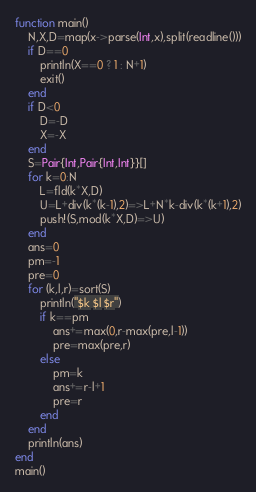Convert code to text. <code><loc_0><loc_0><loc_500><loc_500><_Julia_>function main()
	N,X,D=map(x->parse(Int,x),split(readline()))
	if D==0
		println(X==0 ? 1 : N+1)
		exit()
	end
	if D<0
		D=-D
		X=-X
	end
	S=Pair{Int,Pair{Int,Int}}[]
	for k=0:N
		L=fld(k*X,D)
		U=L+div(k*(k-1),2)=>L+N*k-div(k*(k+1),2)
		push!(S,mod(k*X,D)=>U)
	end
	ans=0
	pm=-1
	pre=0
	for (k,l,r)=sort(S)
		println("$k $l $r")
		if k==pm
			ans+=max(0,r-max(pre,l-1))
			pre=max(pre,r)
		else
			pm=k
			ans+=r-l+1
			pre=r
		end
	end
	println(ans)
end
main()</code> 